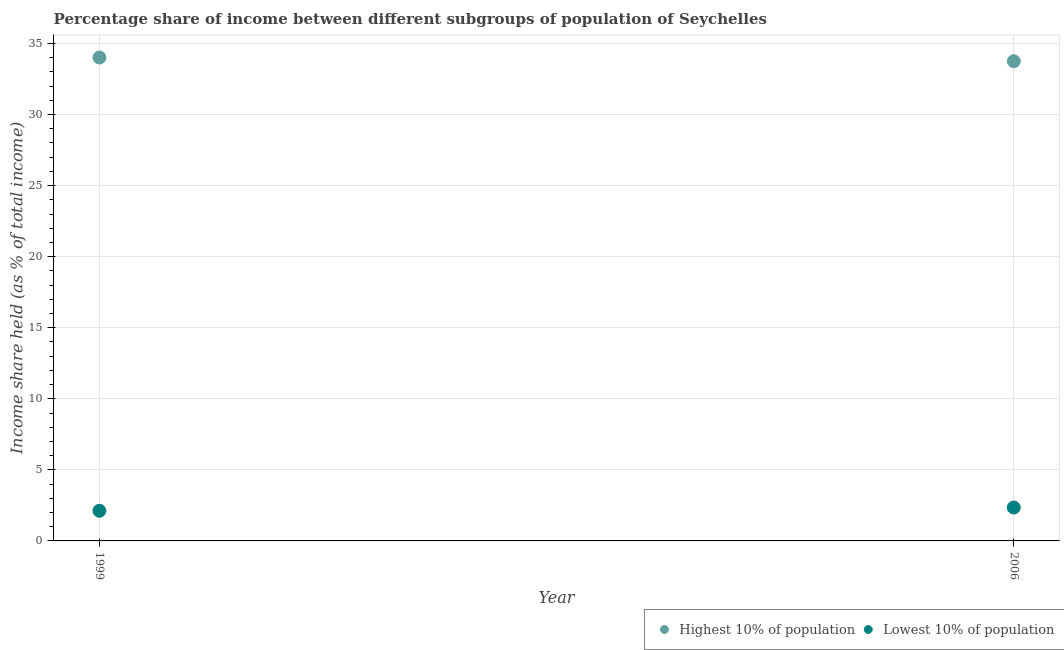What is the income share held by highest 10% of the population in 1999?
Give a very brief answer. 34.01. Across all years, what is the maximum income share held by highest 10% of the population?
Keep it short and to the point. 34.01. Across all years, what is the minimum income share held by lowest 10% of the population?
Your response must be concise. 2.12. In which year was the income share held by lowest 10% of the population maximum?
Offer a terse response. 2006. In which year was the income share held by lowest 10% of the population minimum?
Make the answer very short. 1999. What is the total income share held by highest 10% of the population in the graph?
Give a very brief answer. 67.76. What is the difference between the income share held by lowest 10% of the population in 1999 and that in 2006?
Provide a succinct answer. -0.23. What is the difference between the income share held by lowest 10% of the population in 2006 and the income share held by highest 10% of the population in 1999?
Your response must be concise. -31.66. What is the average income share held by lowest 10% of the population per year?
Offer a very short reply. 2.24. In the year 2006, what is the difference between the income share held by highest 10% of the population and income share held by lowest 10% of the population?
Give a very brief answer. 31.4. What is the ratio of the income share held by lowest 10% of the population in 1999 to that in 2006?
Provide a succinct answer. 0.9. In how many years, is the income share held by lowest 10% of the population greater than the average income share held by lowest 10% of the population taken over all years?
Make the answer very short. 1. Does the income share held by lowest 10% of the population monotonically increase over the years?
Your response must be concise. Yes. Is the income share held by lowest 10% of the population strictly less than the income share held by highest 10% of the population over the years?
Your answer should be compact. Yes. How many dotlines are there?
Provide a succinct answer. 2. What is the difference between two consecutive major ticks on the Y-axis?
Make the answer very short. 5. Are the values on the major ticks of Y-axis written in scientific E-notation?
Your answer should be compact. No. Does the graph contain grids?
Give a very brief answer. Yes. Where does the legend appear in the graph?
Your response must be concise. Bottom right. How many legend labels are there?
Ensure brevity in your answer.  2. How are the legend labels stacked?
Give a very brief answer. Horizontal. What is the title of the graph?
Give a very brief answer. Percentage share of income between different subgroups of population of Seychelles. What is the label or title of the X-axis?
Your response must be concise. Year. What is the label or title of the Y-axis?
Your answer should be compact. Income share held (as % of total income). What is the Income share held (as % of total income) in Highest 10% of population in 1999?
Provide a succinct answer. 34.01. What is the Income share held (as % of total income) of Lowest 10% of population in 1999?
Provide a short and direct response. 2.12. What is the Income share held (as % of total income) of Highest 10% of population in 2006?
Keep it short and to the point. 33.75. What is the Income share held (as % of total income) of Lowest 10% of population in 2006?
Keep it short and to the point. 2.35. Across all years, what is the maximum Income share held (as % of total income) in Highest 10% of population?
Your response must be concise. 34.01. Across all years, what is the maximum Income share held (as % of total income) of Lowest 10% of population?
Make the answer very short. 2.35. Across all years, what is the minimum Income share held (as % of total income) of Highest 10% of population?
Provide a succinct answer. 33.75. Across all years, what is the minimum Income share held (as % of total income) of Lowest 10% of population?
Keep it short and to the point. 2.12. What is the total Income share held (as % of total income) of Highest 10% of population in the graph?
Your response must be concise. 67.76. What is the total Income share held (as % of total income) in Lowest 10% of population in the graph?
Make the answer very short. 4.47. What is the difference between the Income share held (as % of total income) in Highest 10% of population in 1999 and that in 2006?
Make the answer very short. 0.26. What is the difference between the Income share held (as % of total income) of Lowest 10% of population in 1999 and that in 2006?
Provide a succinct answer. -0.23. What is the difference between the Income share held (as % of total income) in Highest 10% of population in 1999 and the Income share held (as % of total income) in Lowest 10% of population in 2006?
Provide a short and direct response. 31.66. What is the average Income share held (as % of total income) of Highest 10% of population per year?
Provide a short and direct response. 33.88. What is the average Income share held (as % of total income) in Lowest 10% of population per year?
Ensure brevity in your answer.  2.23. In the year 1999, what is the difference between the Income share held (as % of total income) of Highest 10% of population and Income share held (as % of total income) of Lowest 10% of population?
Offer a terse response. 31.89. In the year 2006, what is the difference between the Income share held (as % of total income) of Highest 10% of population and Income share held (as % of total income) of Lowest 10% of population?
Keep it short and to the point. 31.4. What is the ratio of the Income share held (as % of total income) in Highest 10% of population in 1999 to that in 2006?
Offer a terse response. 1.01. What is the ratio of the Income share held (as % of total income) of Lowest 10% of population in 1999 to that in 2006?
Give a very brief answer. 0.9. What is the difference between the highest and the second highest Income share held (as % of total income) of Highest 10% of population?
Keep it short and to the point. 0.26. What is the difference between the highest and the second highest Income share held (as % of total income) in Lowest 10% of population?
Your answer should be very brief. 0.23. What is the difference between the highest and the lowest Income share held (as % of total income) in Highest 10% of population?
Keep it short and to the point. 0.26. What is the difference between the highest and the lowest Income share held (as % of total income) of Lowest 10% of population?
Keep it short and to the point. 0.23. 